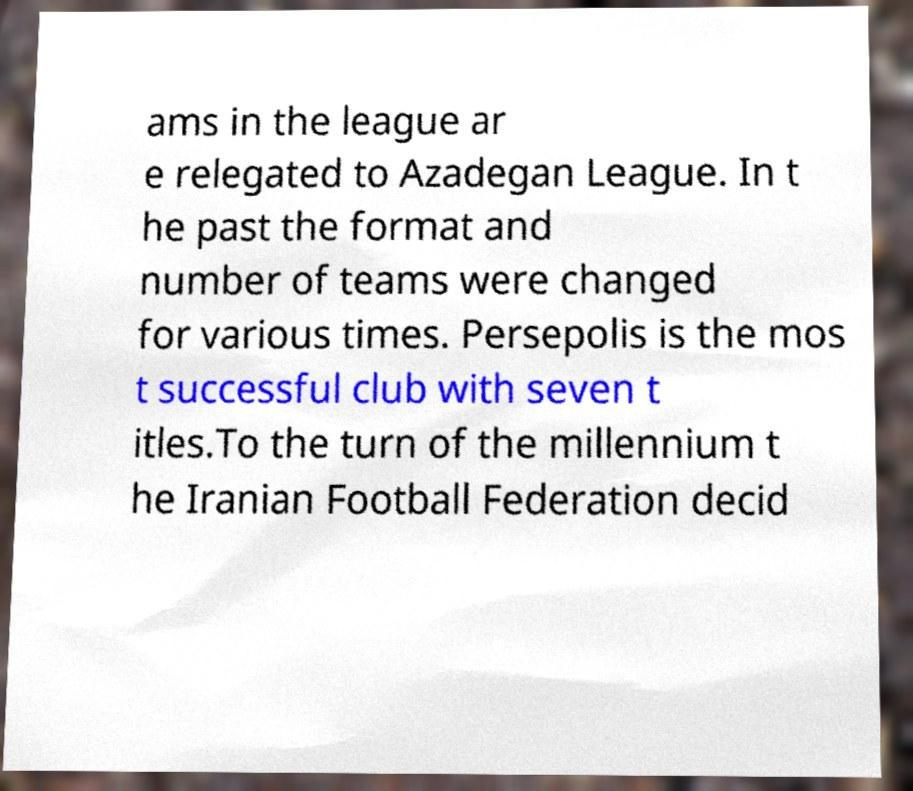I need the written content from this picture converted into text. Can you do that? ams in the league ar e relegated to Azadegan League. In t he past the format and number of teams were changed for various times. Persepolis is the mos t successful club with seven t itles.To the turn of the millennium t he Iranian Football Federation decid 